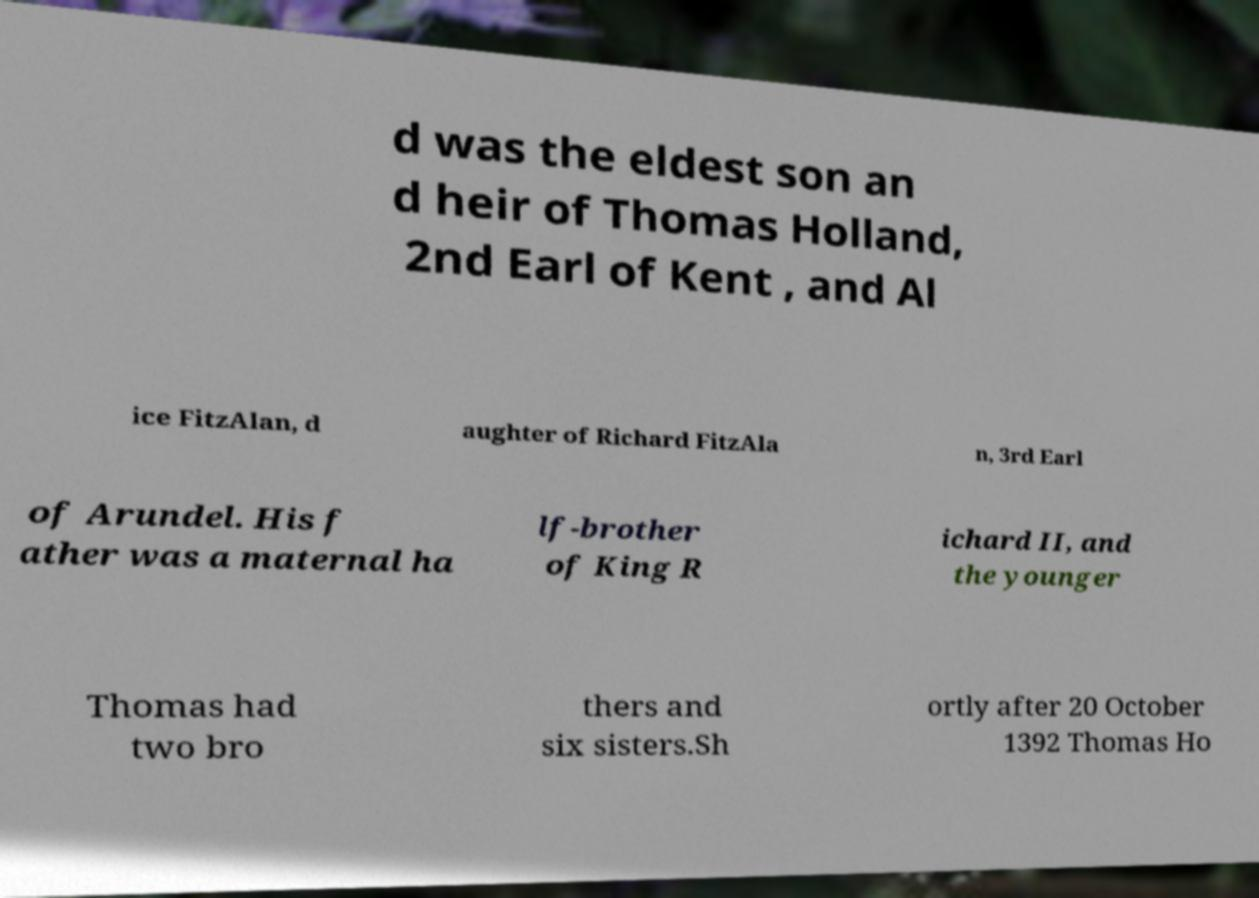Could you assist in decoding the text presented in this image and type it out clearly? d was the eldest son an d heir of Thomas Holland, 2nd Earl of Kent , and Al ice FitzAlan, d aughter of Richard FitzAla n, 3rd Earl of Arundel. His f ather was a maternal ha lf-brother of King R ichard II, and the younger Thomas had two bro thers and six sisters.Sh ortly after 20 October 1392 Thomas Ho 